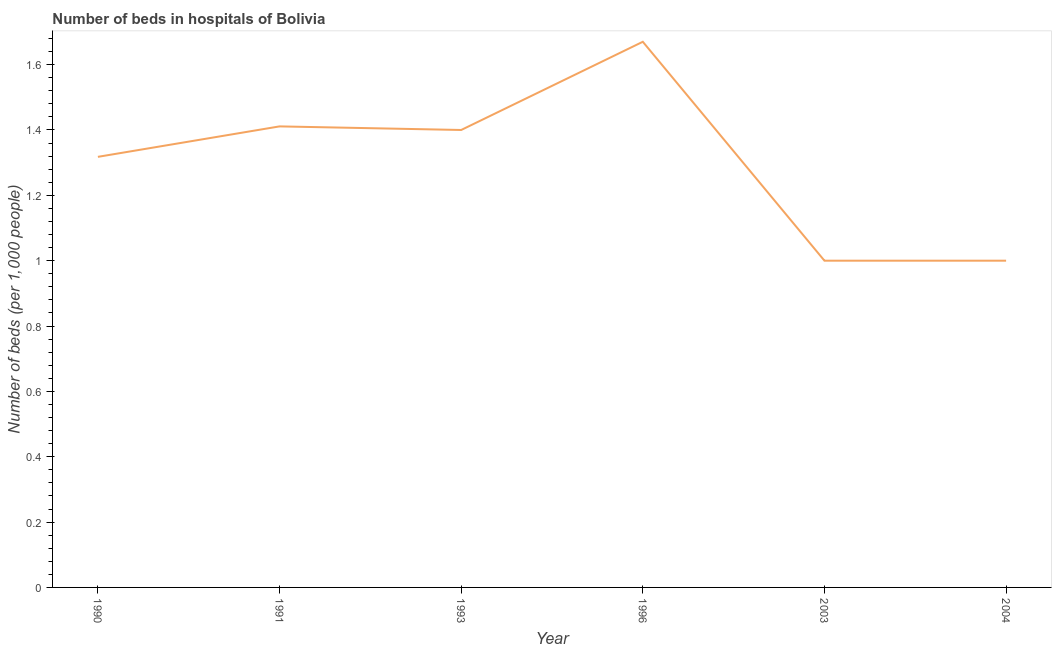What is the number of hospital beds in 1991?
Your response must be concise. 1.41. Across all years, what is the maximum number of hospital beds?
Your answer should be very brief. 1.67. Across all years, what is the minimum number of hospital beds?
Make the answer very short. 1. In which year was the number of hospital beds maximum?
Your answer should be very brief. 1996. In which year was the number of hospital beds minimum?
Give a very brief answer. 2003. What is the sum of the number of hospital beds?
Give a very brief answer. 7.8. What is the difference between the number of hospital beds in 1991 and 1993?
Ensure brevity in your answer.  0.01. What is the average number of hospital beds per year?
Make the answer very short. 1.3. What is the median number of hospital beds?
Ensure brevity in your answer.  1.36. In how many years, is the number of hospital beds greater than 1.3200000000000003 %?
Keep it short and to the point. 3. What is the ratio of the number of hospital beds in 1990 to that in 1996?
Provide a short and direct response. 0.79. Is the difference between the number of hospital beds in 1993 and 2003 greater than the difference between any two years?
Make the answer very short. No. What is the difference between the highest and the second highest number of hospital beds?
Your answer should be compact. 0.26. What is the difference between the highest and the lowest number of hospital beds?
Make the answer very short. 0.67. In how many years, is the number of hospital beds greater than the average number of hospital beds taken over all years?
Your response must be concise. 4. How many years are there in the graph?
Your answer should be compact. 6. Does the graph contain any zero values?
Offer a very short reply. No. Does the graph contain grids?
Your answer should be very brief. No. What is the title of the graph?
Give a very brief answer. Number of beds in hospitals of Bolivia. What is the label or title of the Y-axis?
Your response must be concise. Number of beds (per 1,0 people). What is the Number of beds (per 1,000 people) in 1990?
Your answer should be very brief. 1.32. What is the Number of beds (per 1,000 people) of 1991?
Offer a terse response. 1.41. What is the Number of beds (per 1,000 people) in 1993?
Give a very brief answer. 1.4. What is the Number of beds (per 1,000 people) of 1996?
Give a very brief answer. 1.67. What is the Number of beds (per 1,000 people) of 2003?
Offer a terse response. 1. What is the Number of beds (per 1,000 people) in 2004?
Your response must be concise. 1. What is the difference between the Number of beds (per 1,000 people) in 1990 and 1991?
Provide a succinct answer. -0.09. What is the difference between the Number of beds (per 1,000 people) in 1990 and 1993?
Your answer should be very brief. -0.08. What is the difference between the Number of beds (per 1,000 people) in 1990 and 1996?
Provide a succinct answer. -0.35. What is the difference between the Number of beds (per 1,000 people) in 1990 and 2003?
Provide a succinct answer. 0.32. What is the difference between the Number of beds (per 1,000 people) in 1990 and 2004?
Offer a terse response. 0.32. What is the difference between the Number of beds (per 1,000 people) in 1991 and 1993?
Ensure brevity in your answer.  0.01. What is the difference between the Number of beds (per 1,000 people) in 1991 and 1996?
Make the answer very short. -0.26. What is the difference between the Number of beds (per 1,000 people) in 1991 and 2003?
Provide a succinct answer. 0.41. What is the difference between the Number of beds (per 1,000 people) in 1991 and 2004?
Offer a very short reply. 0.41. What is the difference between the Number of beds (per 1,000 people) in 1993 and 1996?
Your answer should be compact. -0.27. What is the difference between the Number of beds (per 1,000 people) in 1993 and 2003?
Keep it short and to the point. 0.4. What is the difference between the Number of beds (per 1,000 people) in 1996 and 2003?
Provide a succinct answer. 0.67. What is the difference between the Number of beds (per 1,000 people) in 1996 and 2004?
Offer a terse response. 0.67. What is the difference between the Number of beds (per 1,000 people) in 2003 and 2004?
Your answer should be very brief. 0. What is the ratio of the Number of beds (per 1,000 people) in 1990 to that in 1991?
Ensure brevity in your answer.  0.93. What is the ratio of the Number of beds (per 1,000 people) in 1990 to that in 1993?
Provide a short and direct response. 0.94. What is the ratio of the Number of beds (per 1,000 people) in 1990 to that in 1996?
Your answer should be very brief. 0.79. What is the ratio of the Number of beds (per 1,000 people) in 1990 to that in 2003?
Provide a succinct answer. 1.32. What is the ratio of the Number of beds (per 1,000 people) in 1990 to that in 2004?
Offer a terse response. 1.32. What is the ratio of the Number of beds (per 1,000 people) in 1991 to that in 1993?
Offer a very short reply. 1.01. What is the ratio of the Number of beds (per 1,000 people) in 1991 to that in 1996?
Provide a short and direct response. 0.84. What is the ratio of the Number of beds (per 1,000 people) in 1991 to that in 2003?
Make the answer very short. 1.41. What is the ratio of the Number of beds (per 1,000 people) in 1991 to that in 2004?
Provide a succinct answer. 1.41. What is the ratio of the Number of beds (per 1,000 people) in 1993 to that in 1996?
Keep it short and to the point. 0.84. What is the ratio of the Number of beds (per 1,000 people) in 1993 to that in 2003?
Your answer should be compact. 1.4. What is the ratio of the Number of beds (per 1,000 people) in 1996 to that in 2003?
Your answer should be compact. 1.67. What is the ratio of the Number of beds (per 1,000 people) in 1996 to that in 2004?
Your answer should be compact. 1.67. 